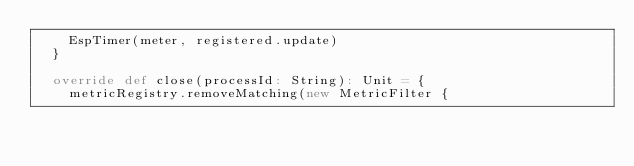<code> <loc_0><loc_0><loc_500><loc_500><_Scala_>    EspTimer(meter, registered.update)
  }

  override def close(processId: String): Unit = {
    metricRegistry.removeMatching(new MetricFilter {</code> 